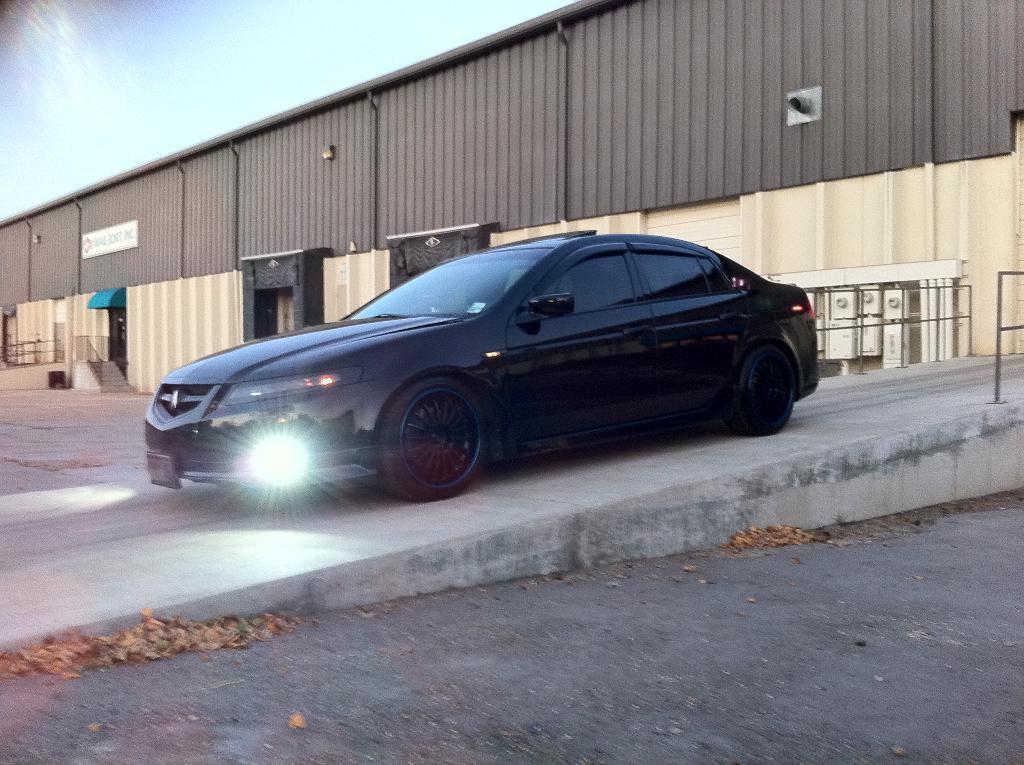Can you describe this image briefly? In this image in the center there is a car which is black in colour moving on the ramp. In the background there is a tin shed. In the front on the ground there are dry leaves. 